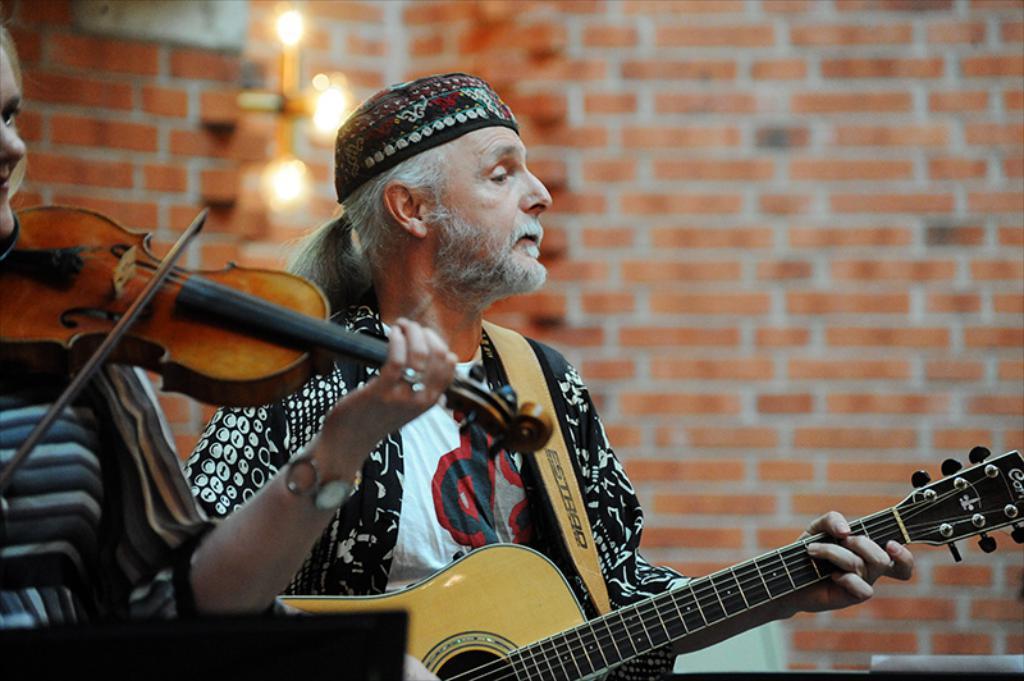Could you give a brief overview of what you see in this image? This image consists of two persons. The one who left side is women. She is holding a violin in her hand. She has a watch and ring to her hand. Beside her there is man in the middle of the image. He is wearing black color dress, he is playing guitar. He also has cap on his head. Behind him there are lights on the top. The wall is with bricks. 